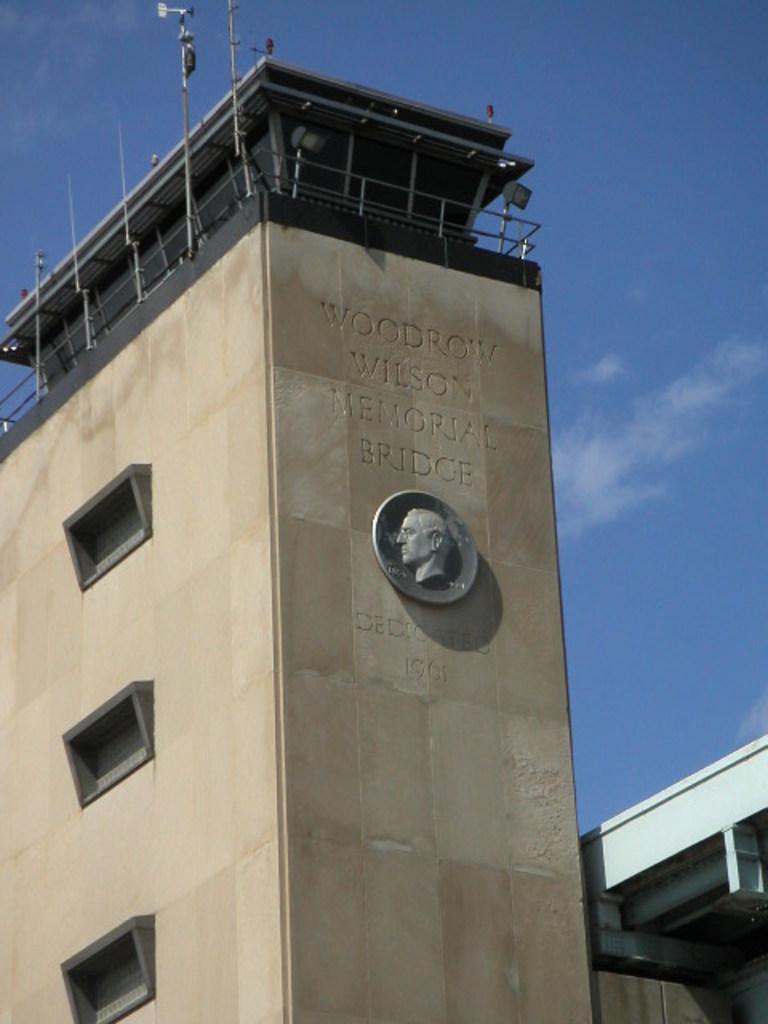In one or two sentences, can you explain what this image depicts? In this picture we can see few buildings and few metal rods on the building. 